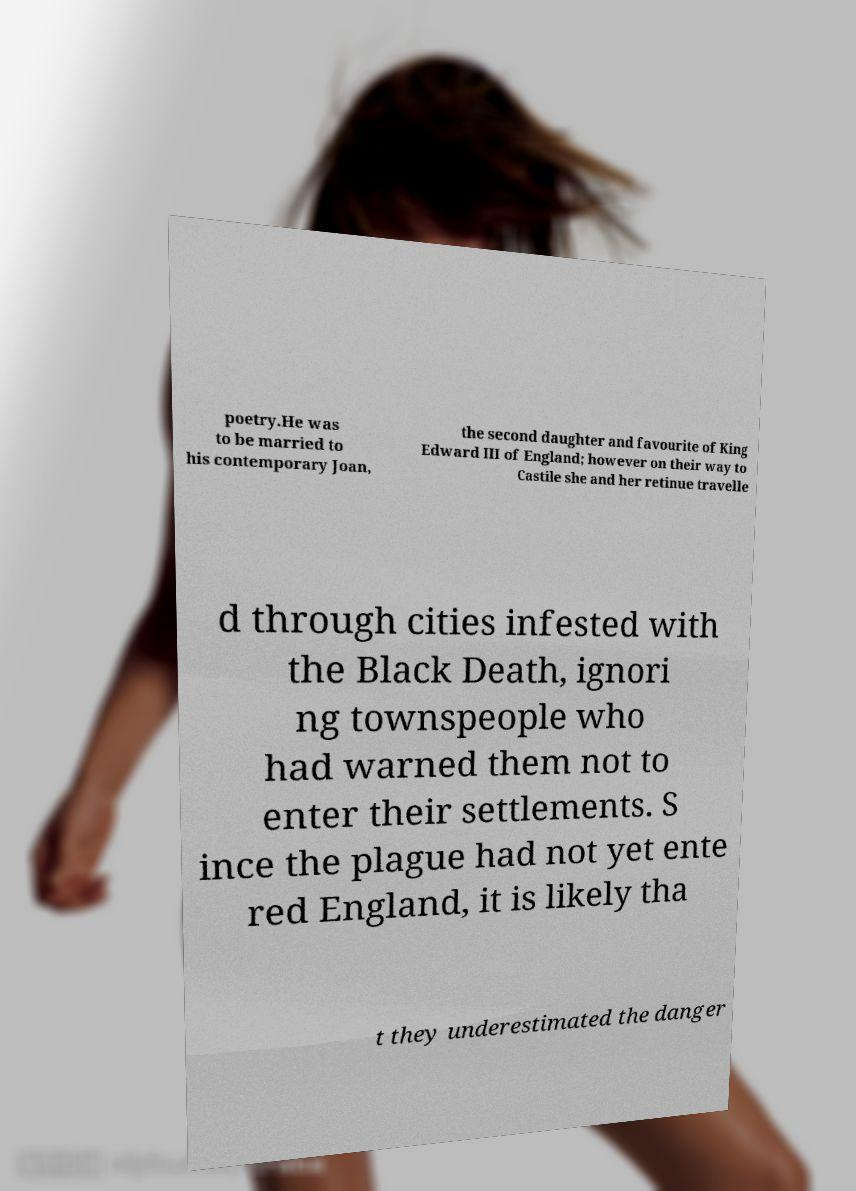For documentation purposes, I need the text within this image transcribed. Could you provide that? poetry.He was to be married to his contemporary Joan, the second daughter and favourite of King Edward III of England; however on their way to Castile she and her retinue travelle d through cities infested with the Black Death, ignori ng townspeople who had warned them not to enter their settlements. S ince the plague had not yet ente red England, it is likely tha t they underestimated the danger 